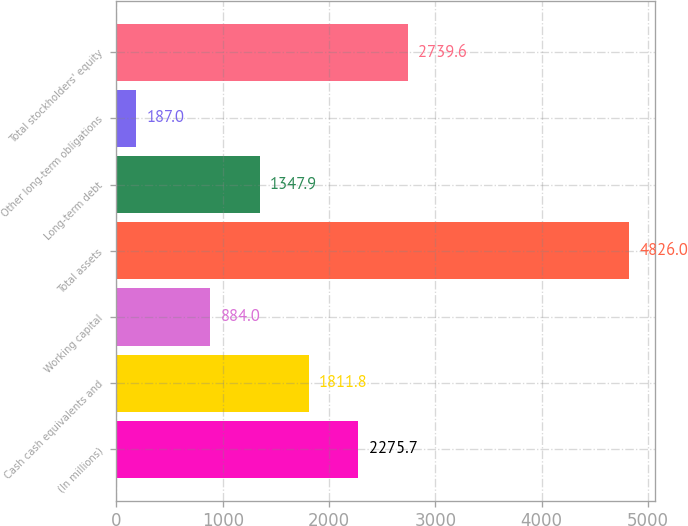Convert chart to OTSL. <chart><loc_0><loc_0><loc_500><loc_500><bar_chart><fcel>(In millions)<fcel>Cash cash equivalents and<fcel>Working capital<fcel>Total assets<fcel>Long-term debt<fcel>Other long-term obligations<fcel>Total stockholders' equity<nl><fcel>2275.7<fcel>1811.8<fcel>884<fcel>4826<fcel>1347.9<fcel>187<fcel>2739.6<nl></chart> 